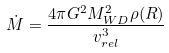Convert formula to latex. <formula><loc_0><loc_0><loc_500><loc_500>\dot { M } = \frac { 4 \pi G ^ { 2 } M _ { W D } ^ { 2 } \rho ( R ) } { v _ { r e l } ^ { 3 } }</formula> 